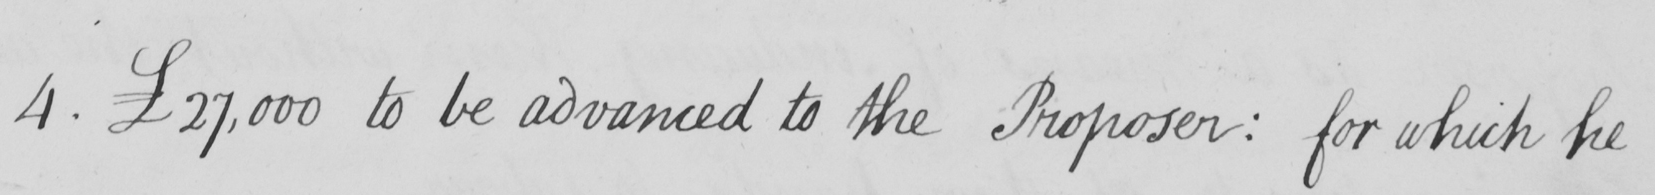Can you tell me what this handwritten text says? 4 . £27,000 to be advanced to the Proposer :  for which he 